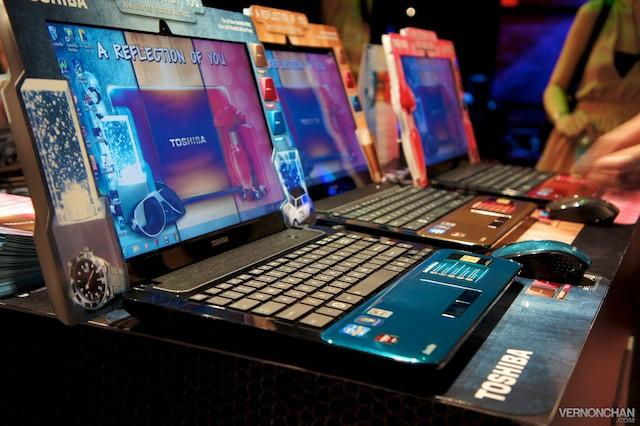What kind of label is on the desk? Please explain your reasoning. brand. A toshiba pad is near a computer. toshiba is a brand. 